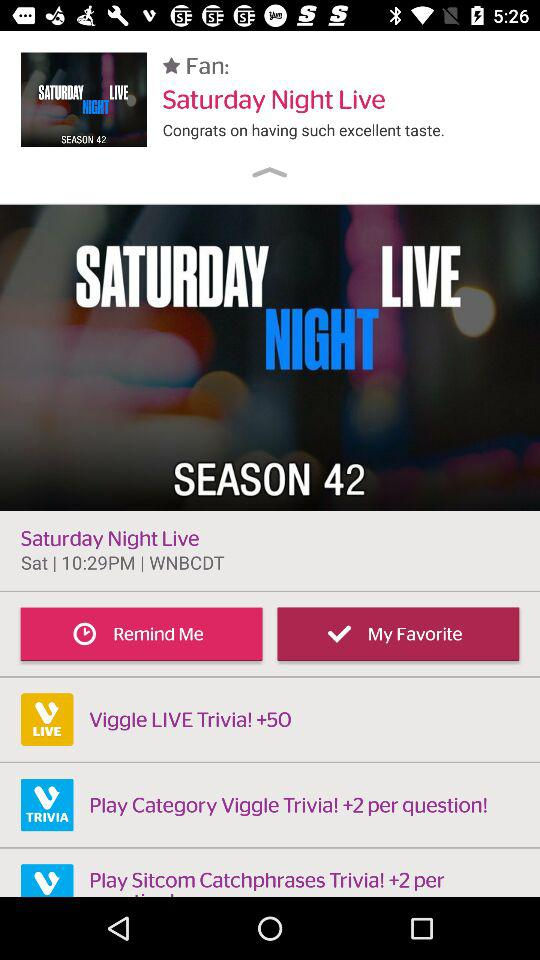What is the season number? The season number is 42. 